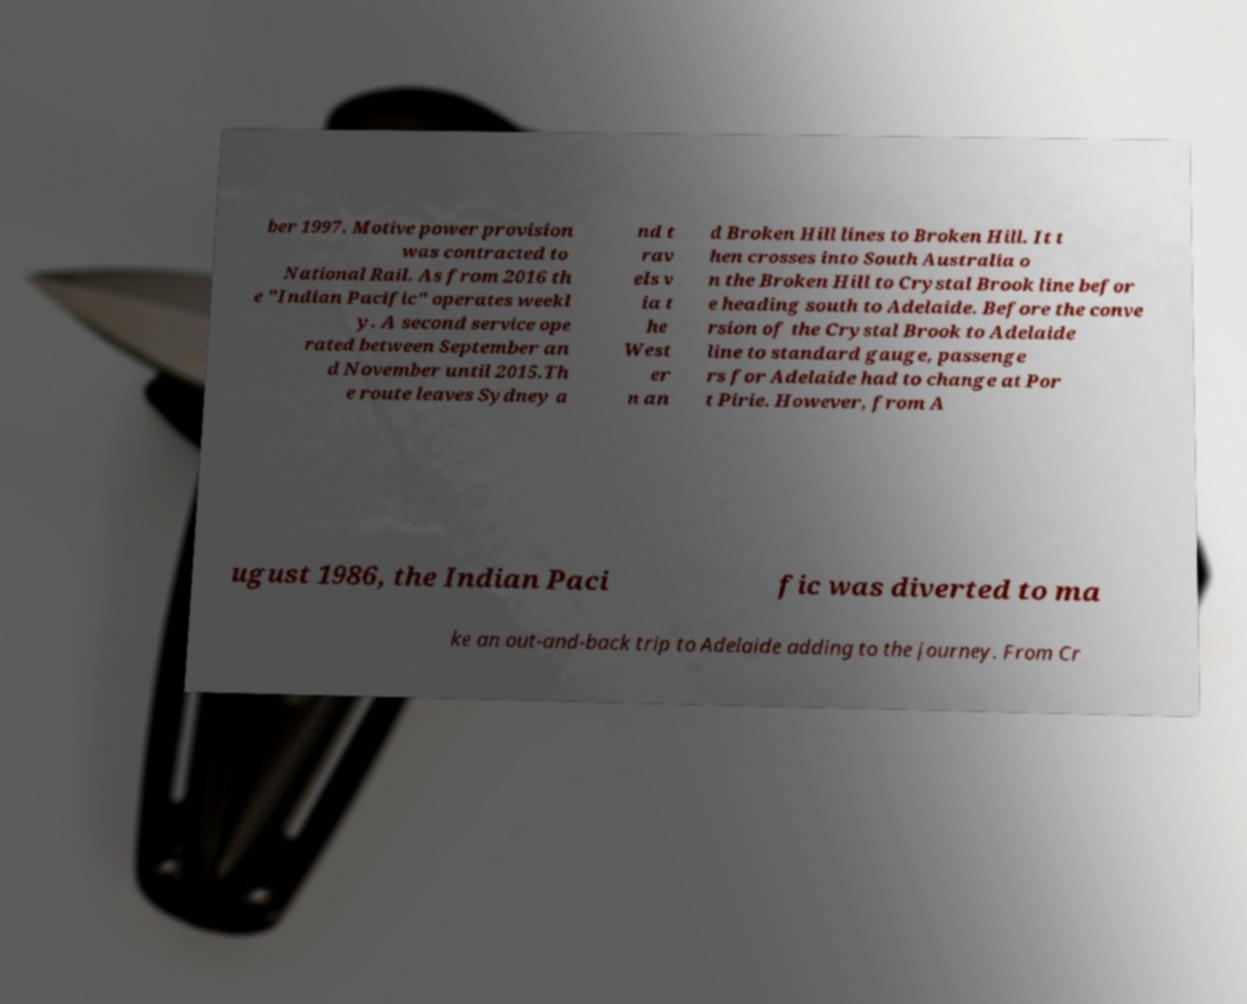Could you extract and type out the text from this image? ber 1997. Motive power provision was contracted to National Rail. As from 2016 th e "Indian Pacific" operates weekl y. A second service ope rated between September an d November until 2015.Th e route leaves Sydney a nd t rav els v ia t he West er n an d Broken Hill lines to Broken Hill. It t hen crosses into South Australia o n the Broken Hill to Crystal Brook line befor e heading south to Adelaide. Before the conve rsion of the Crystal Brook to Adelaide line to standard gauge, passenge rs for Adelaide had to change at Por t Pirie. However, from A ugust 1986, the Indian Paci fic was diverted to ma ke an out-and-back trip to Adelaide adding to the journey. From Cr 